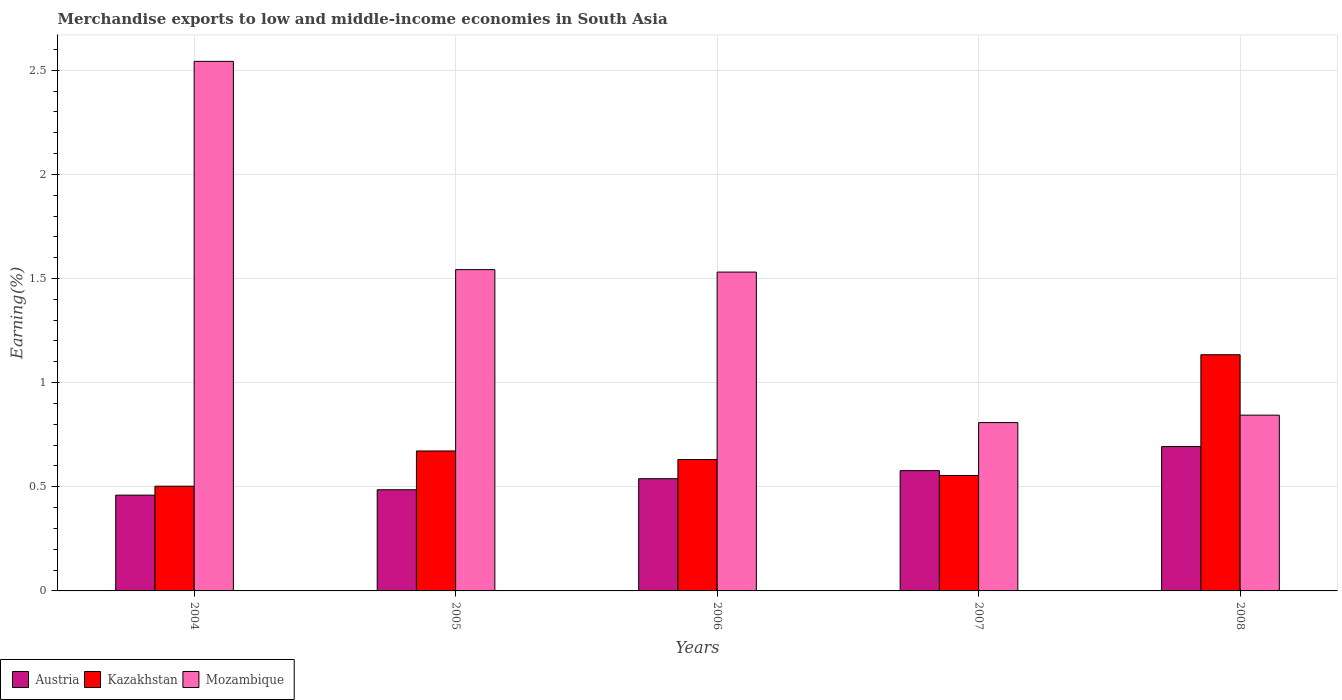How many different coloured bars are there?
Ensure brevity in your answer.  3. How many groups of bars are there?
Make the answer very short. 5. Are the number of bars on each tick of the X-axis equal?
Give a very brief answer. Yes. How many bars are there on the 3rd tick from the left?
Keep it short and to the point. 3. In how many cases, is the number of bars for a given year not equal to the number of legend labels?
Offer a terse response. 0. What is the percentage of amount earned from merchandise exports in Austria in 2005?
Provide a short and direct response. 0.49. Across all years, what is the maximum percentage of amount earned from merchandise exports in Kazakhstan?
Your response must be concise. 1.13. Across all years, what is the minimum percentage of amount earned from merchandise exports in Kazakhstan?
Offer a very short reply. 0.5. What is the total percentage of amount earned from merchandise exports in Kazakhstan in the graph?
Your response must be concise. 3.49. What is the difference between the percentage of amount earned from merchandise exports in Austria in 2005 and that in 2007?
Your answer should be compact. -0.09. What is the difference between the percentage of amount earned from merchandise exports in Mozambique in 2008 and the percentage of amount earned from merchandise exports in Austria in 2005?
Offer a terse response. 0.36. What is the average percentage of amount earned from merchandise exports in Austria per year?
Make the answer very short. 0.55. In the year 2005, what is the difference between the percentage of amount earned from merchandise exports in Mozambique and percentage of amount earned from merchandise exports in Austria?
Your answer should be compact. 1.06. What is the ratio of the percentage of amount earned from merchandise exports in Austria in 2004 to that in 2006?
Your response must be concise. 0.85. What is the difference between the highest and the second highest percentage of amount earned from merchandise exports in Kazakhstan?
Make the answer very short. 0.46. What is the difference between the highest and the lowest percentage of amount earned from merchandise exports in Mozambique?
Keep it short and to the point. 1.73. Is the sum of the percentage of amount earned from merchandise exports in Kazakhstan in 2006 and 2008 greater than the maximum percentage of amount earned from merchandise exports in Mozambique across all years?
Your response must be concise. No. What does the 3rd bar from the left in 2004 represents?
Keep it short and to the point. Mozambique. What does the 3rd bar from the right in 2004 represents?
Your answer should be compact. Austria. How many years are there in the graph?
Your answer should be compact. 5. What is the difference between two consecutive major ticks on the Y-axis?
Offer a terse response. 0.5. Does the graph contain any zero values?
Offer a terse response. No. Does the graph contain grids?
Keep it short and to the point. Yes. Where does the legend appear in the graph?
Your answer should be very brief. Bottom left. How are the legend labels stacked?
Your response must be concise. Horizontal. What is the title of the graph?
Offer a terse response. Merchandise exports to low and middle-income economies in South Asia. What is the label or title of the Y-axis?
Give a very brief answer. Earning(%). What is the Earning(%) in Austria in 2004?
Make the answer very short. 0.46. What is the Earning(%) in Kazakhstan in 2004?
Keep it short and to the point. 0.5. What is the Earning(%) in Mozambique in 2004?
Your response must be concise. 2.54. What is the Earning(%) in Austria in 2005?
Provide a succinct answer. 0.49. What is the Earning(%) of Kazakhstan in 2005?
Offer a very short reply. 0.67. What is the Earning(%) of Mozambique in 2005?
Your answer should be compact. 1.54. What is the Earning(%) in Austria in 2006?
Give a very brief answer. 0.54. What is the Earning(%) in Kazakhstan in 2006?
Make the answer very short. 0.63. What is the Earning(%) in Mozambique in 2006?
Your answer should be compact. 1.53. What is the Earning(%) of Austria in 2007?
Provide a succinct answer. 0.58. What is the Earning(%) of Kazakhstan in 2007?
Ensure brevity in your answer.  0.55. What is the Earning(%) in Mozambique in 2007?
Keep it short and to the point. 0.81. What is the Earning(%) in Austria in 2008?
Provide a succinct answer. 0.69. What is the Earning(%) in Kazakhstan in 2008?
Give a very brief answer. 1.13. What is the Earning(%) of Mozambique in 2008?
Make the answer very short. 0.84. Across all years, what is the maximum Earning(%) of Austria?
Make the answer very short. 0.69. Across all years, what is the maximum Earning(%) in Kazakhstan?
Ensure brevity in your answer.  1.13. Across all years, what is the maximum Earning(%) of Mozambique?
Your response must be concise. 2.54. Across all years, what is the minimum Earning(%) in Austria?
Ensure brevity in your answer.  0.46. Across all years, what is the minimum Earning(%) in Kazakhstan?
Make the answer very short. 0.5. Across all years, what is the minimum Earning(%) in Mozambique?
Keep it short and to the point. 0.81. What is the total Earning(%) of Austria in the graph?
Offer a terse response. 2.76. What is the total Earning(%) of Kazakhstan in the graph?
Make the answer very short. 3.49. What is the total Earning(%) of Mozambique in the graph?
Your answer should be very brief. 7.27. What is the difference between the Earning(%) of Austria in 2004 and that in 2005?
Your answer should be very brief. -0.03. What is the difference between the Earning(%) in Kazakhstan in 2004 and that in 2005?
Give a very brief answer. -0.17. What is the difference between the Earning(%) in Austria in 2004 and that in 2006?
Offer a terse response. -0.08. What is the difference between the Earning(%) in Kazakhstan in 2004 and that in 2006?
Keep it short and to the point. -0.13. What is the difference between the Earning(%) in Mozambique in 2004 and that in 2006?
Offer a very short reply. 1.01. What is the difference between the Earning(%) in Austria in 2004 and that in 2007?
Your answer should be very brief. -0.12. What is the difference between the Earning(%) of Kazakhstan in 2004 and that in 2007?
Provide a short and direct response. -0.05. What is the difference between the Earning(%) of Mozambique in 2004 and that in 2007?
Provide a short and direct response. 1.73. What is the difference between the Earning(%) in Austria in 2004 and that in 2008?
Provide a short and direct response. -0.23. What is the difference between the Earning(%) of Kazakhstan in 2004 and that in 2008?
Your answer should be very brief. -0.63. What is the difference between the Earning(%) of Mozambique in 2004 and that in 2008?
Keep it short and to the point. 1.7. What is the difference between the Earning(%) of Austria in 2005 and that in 2006?
Provide a succinct answer. -0.05. What is the difference between the Earning(%) of Kazakhstan in 2005 and that in 2006?
Your answer should be compact. 0.04. What is the difference between the Earning(%) in Mozambique in 2005 and that in 2006?
Your response must be concise. 0.01. What is the difference between the Earning(%) of Austria in 2005 and that in 2007?
Give a very brief answer. -0.09. What is the difference between the Earning(%) in Kazakhstan in 2005 and that in 2007?
Provide a succinct answer. 0.12. What is the difference between the Earning(%) in Mozambique in 2005 and that in 2007?
Provide a short and direct response. 0.73. What is the difference between the Earning(%) in Austria in 2005 and that in 2008?
Give a very brief answer. -0.21. What is the difference between the Earning(%) of Kazakhstan in 2005 and that in 2008?
Keep it short and to the point. -0.46. What is the difference between the Earning(%) of Mozambique in 2005 and that in 2008?
Give a very brief answer. 0.7. What is the difference between the Earning(%) of Austria in 2006 and that in 2007?
Your answer should be very brief. -0.04. What is the difference between the Earning(%) of Kazakhstan in 2006 and that in 2007?
Offer a very short reply. 0.08. What is the difference between the Earning(%) in Mozambique in 2006 and that in 2007?
Make the answer very short. 0.72. What is the difference between the Earning(%) in Austria in 2006 and that in 2008?
Your answer should be compact. -0.15. What is the difference between the Earning(%) in Kazakhstan in 2006 and that in 2008?
Keep it short and to the point. -0.5. What is the difference between the Earning(%) of Mozambique in 2006 and that in 2008?
Offer a very short reply. 0.69. What is the difference between the Earning(%) of Austria in 2007 and that in 2008?
Make the answer very short. -0.12. What is the difference between the Earning(%) of Kazakhstan in 2007 and that in 2008?
Keep it short and to the point. -0.58. What is the difference between the Earning(%) of Mozambique in 2007 and that in 2008?
Give a very brief answer. -0.04. What is the difference between the Earning(%) of Austria in 2004 and the Earning(%) of Kazakhstan in 2005?
Ensure brevity in your answer.  -0.21. What is the difference between the Earning(%) of Austria in 2004 and the Earning(%) of Mozambique in 2005?
Offer a very short reply. -1.08. What is the difference between the Earning(%) of Kazakhstan in 2004 and the Earning(%) of Mozambique in 2005?
Give a very brief answer. -1.04. What is the difference between the Earning(%) in Austria in 2004 and the Earning(%) in Kazakhstan in 2006?
Keep it short and to the point. -0.17. What is the difference between the Earning(%) in Austria in 2004 and the Earning(%) in Mozambique in 2006?
Provide a short and direct response. -1.07. What is the difference between the Earning(%) in Kazakhstan in 2004 and the Earning(%) in Mozambique in 2006?
Ensure brevity in your answer.  -1.03. What is the difference between the Earning(%) in Austria in 2004 and the Earning(%) in Kazakhstan in 2007?
Make the answer very short. -0.09. What is the difference between the Earning(%) in Austria in 2004 and the Earning(%) in Mozambique in 2007?
Provide a short and direct response. -0.35. What is the difference between the Earning(%) of Kazakhstan in 2004 and the Earning(%) of Mozambique in 2007?
Your answer should be very brief. -0.31. What is the difference between the Earning(%) in Austria in 2004 and the Earning(%) in Kazakhstan in 2008?
Offer a terse response. -0.67. What is the difference between the Earning(%) of Austria in 2004 and the Earning(%) of Mozambique in 2008?
Keep it short and to the point. -0.38. What is the difference between the Earning(%) of Kazakhstan in 2004 and the Earning(%) of Mozambique in 2008?
Your answer should be compact. -0.34. What is the difference between the Earning(%) of Austria in 2005 and the Earning(%) of Kazakhstan in 2006?
Provide a succinct answer. -0.15. What is the difference between the Earning(%) of Austria in 2005 and the Earning(%) of Mozambique in 2006?
Your answer should be compact. -1.05. What is the difference between the Earning(%) of Kazakhstan in 2005 and the Earning(%) of Mozambique in 2006?
Make the answer very short. -0.86. What is the difference between the Earning(%) in Austria in 2005 and the Earning(%) in Kazakhstan in 2007?
Give a very brief answer. -0.07. What is the difference between the Earning(%) of Austria in 2005 and the Earning(%) of Mozambique in 2007?
Keep it short and to the point. -0.32. What is the difference between the Earning(%) in Kazakhstan in 2005 and the Earning(%) in Mozambique in 2007?
Provide a short and direct response. -0.14. What is the difference between the Earning(%) in Austria in 2005 and the Earning(%) in Kazakhstan in 2008?
Your response must be concise. -0.65. What is the difference between the Earning(%) in Austria in 2005 and the Earning(%) in Mozambique in 2008?
Ensure brevity in your answer.  -0.36. What is the difference between the Earning(%) of Kazakhstan in 2005 and the Earning(%) of Mozambique in 2008?
Offer a terse response. -0.17. What is the difference between the Earning(%) in Austria in 2006 and the Earning(%) in Kazakhstan in 2007?
Offer a terse response. -0.02. What is the difference between the Earning(%) of Austria in 2006 and the Earning(%) of Mozambique in 2007?
Make the answer very short. -0.27. What is the difference between the Earning(%) of Kazakhstan in 2006 and the Earning(%) of Mozambique in 2007?
Keep it short and to the point. -0.18. What is the difference between the Earning(%) of Austria in 2006 and the Earning(%) of Kazakhstan in 2008?
Your answer should be compact. -0.6. What is the difference between the Earning(%) in Austria in 2006 and the Earning(%) in Mozambique in 2008?
Give a very brief answer. -0.3. What is the difference between the Earning(%) of Kazakhstan in 2006 and the Earning(%) of Mozambique in 2008?
Provide a succinct answer. -0.21. What is the difference between the Earning(%) in Austria in 2007 and the Earning(%) in Kazakhstan in 2008?
Provide a short and direct response. -0.56. What is the difference between the Earning(%) in Austria in 2007 and the Earning(%) in Mozambique in 2008?
Offer a very short reply. -0.27. What is the difference between the Earning(%) in Kazakhstan in 2007 and the Earning(%) in Mozambique in 2008?
Provide a short and direct response. -0.29. What is the average Earning(%) of Austria per year?
Keep it short and to the point. 0.55. What is the average Earning(%) of Kazakhstan per year?
Make the answer very short. 0.7. What is the average Earning(%) of Mozambique per year?
Your answer should be very brief. 1.45. In the year 2004, what is the difference between the Earning(%) in Austria and Earning(%) in Kazakhstan?
Make the answer very short. -0.04. In the year 2004, what is the difference between the Earning(%) in Austria and Earning(%) in Mozambique?
Your answer should be compact. -2.08. In the year 2004, what is the difference between the Earning(%) in Kazakhstan and Earning(%) in Mozambique?
Keep it short and to the point. -2.04. In the year 2005, what is the difference between the Earning(%) in Austria and Earning(%) in Kazakhstan?
Provide a short and direct response. -0.19. In the year 2005, what is the difference between the Earning(%) of Austria and Earning(%) of Mozambique?
Your response must be concise. -1.06. In the year 2005, what is the difference between the Earning(%) of Kazakhstan and Earning(%) of Mozambique?
Ensure brevity in your answer.  -0.87. In the year 2006, what is the difference between the Earning(%) in Austria and Earning(%) in Kazakhstan?
Keep it short and to the point. -0.09. In the year 2006, what is the difference between the Earning(%) of Austria and Earning(%) of Mozambique?
Provide a short and direct response. -0.99. In the year 2006, what is the difference between the Earning(%) of Kazakhstan and Earning(%) of Mozambique?
Ensure brevity in your answer.  -0.9. In the year 2007, what is the difference between the Earning(%) in Austria and Earning(%) in Kazakhstan?
Provide a succinct answer. 0.02. In the year 2007, what is the difference between the Earning(%) of Austria and Earning(%) of Mozambique?
Offer a terse response. -0.23. In the year 2007, what is the difference between the Earning(%) in Kazakhstan and Earning(%) in Mozambique?
Give a very brief answer. -0.25. In the year 2008, what is the difference between the Earning(%) in Austria and Earning(%) in Kazakhstan?
Ensure brevity in your answer.  -0.44. In the year 2008, what is the difference between the Earning(%) in Austria and Earning(%) in Mozambique?
Your response must be concise. -0.15. In the year 2008, what is the difference between the Earning(%) of Kazakhstan and Earning(%) of Mozambique?
Ensure brevity in your answer.  0.29. What is the ratio of the Earning(%) of Austria in 2004 to that in 2005?
Your answer should be very brief. 0.95. What is the ratio of the Earning(%) of Kazakhstan in 2004 to that in 2005?
Make the answer very short. 0.75. What is the ratio of the Earning(%) in Mozambique in 2004 to that in 2005?
Make the answer very short. 1.65. What is the ratio of the Earning(%) in Austria in 2004 to that in 2006?
Ensure brevity in your answer.  0.85. What is the ratio of the Earning(%) in Kazakhstan in 2004 to that in 2006?
Ensure brevity in your answer.  0.8. What is the ratio of the Earning(%) in Mozambique in 2004 to that in 2006?
Provide a succinct answer. 1.66. What is the ratio of the Earning(%) of Austria in 2004 to that in 2007?
Your response must be concise. 0.8. What is the ratio of the Earning(%) in Kazakhstan in 2004 to that in 2007?
Offer a very short reply. 0.91. What is the ratio of the Earning(%) in Mozambique in 2004 to that in 2007?
Offer a terse response. 3.15. What is the ratio of the Earning(%) of Austria in 2004 to that in 2008?
Offer a very short reply. 0.66. What is the ratio of the Earning(%) of Kazakhstan in 2004 to that in 2008?
Your response must be concise. 0.44. What is the ratio of the Earning(%) of Mozambique in 2004 to that in 2008?
Your answer should be very brief. 3.01. What is the ratio of the Earning(%) in Austria in 2005 to that in 2006?
Keep it short and to the point. 0.9. What is the ratio of the Earning(%) in Kazakhstan in 2005 to that in 2006?
Ensure brevity in your answer.  1.07. What is the ratio of the Earning(%) of Mozambique in 2005 to that in 2006?
Make the answer very short. 1.01. What is the ratio of the Earning(%) of Austria in 2005 to that in 2007?
Your response must be concise. 0.84. What is the ratio of the Earning(%) in Kazakhstan in 2005 to that in 2007?
Give a very brief answer. 1.21. What is the ratio of the Earning(%) in Mozambique in 2005 to that in 2007?
Your answer should be compact. 1.91. What is the ratio of the Earning(%) in Austria in 2005 to that in 2008?
Give a very brief answer. 0.7. What is the ratio of the Earning(%) of Kazakhstan in 2005 to that in 2008?
Provide a short and direct response. 0.59. What is the ratio of the Earning(%) of Mozambique in 2005 to that in 2008?
Give a very brief answer. 1.83. What is the ratio of the Earning(%) of Austria in 2006 to that in 2007?
Ensure brevity in your answer.  0.93. What is the ratio of the Earning(%) of Kazakhstan in 2006 to that in 2007?
Your answer should be compact. 1.14. What is the ratio of the Earning(%) in Mozambique in 2006 to that in 2007?
Ensure brevity in your answer.  1.89. What is the ratio of the Earning(%) of Austria in 2006 to that in 2008?
Offer a very short reply. 0.78. What is the ratio of the Earning(%) of Kazakhstan in 2006 to that in 2008?
Offer a terse response. 0.56. What is the ratio of the Earning(%) in Mozambique in 2006 to that in 2008?
Your answer should be compact. 1.81. What is the ratio of the Earning(%) of Austria in 2007 to that in 2008?
Ensure brevity in your answer.  0.83. What is the ratio of the Earning(%) in Kazakhstan in 2007 to that in 2008?
Your answer should be very brief. 0.49. What is the ratio of the Earning(%) of Mozambique in 2007 to that in 2008?
Give a very brief answer. 0.96. What is the difference between the highest and the second highest Earning(%) of Austria?
Ensure brevity in your answer.  0.12. What is the difference between the highest and the second highest Earning(%) in Kazakhstan?
Offer a terse response. 0.46. What is the difference between the highest and the second highest Earning(%) in Mozambique?
Ensure brevity in your answer.  1. What is the difference between the highest and the lowest Earning(%) of Austria?
Provide a short and direct response. 0.23. What is the difference between the highest and the lowest Earning(%) in Kazakhstan?
Your answer should be compact. 0.63. What is the difference between the highest and the lowest Earning(%) in Mozambique?
Give a very brief answer. 1.73. 